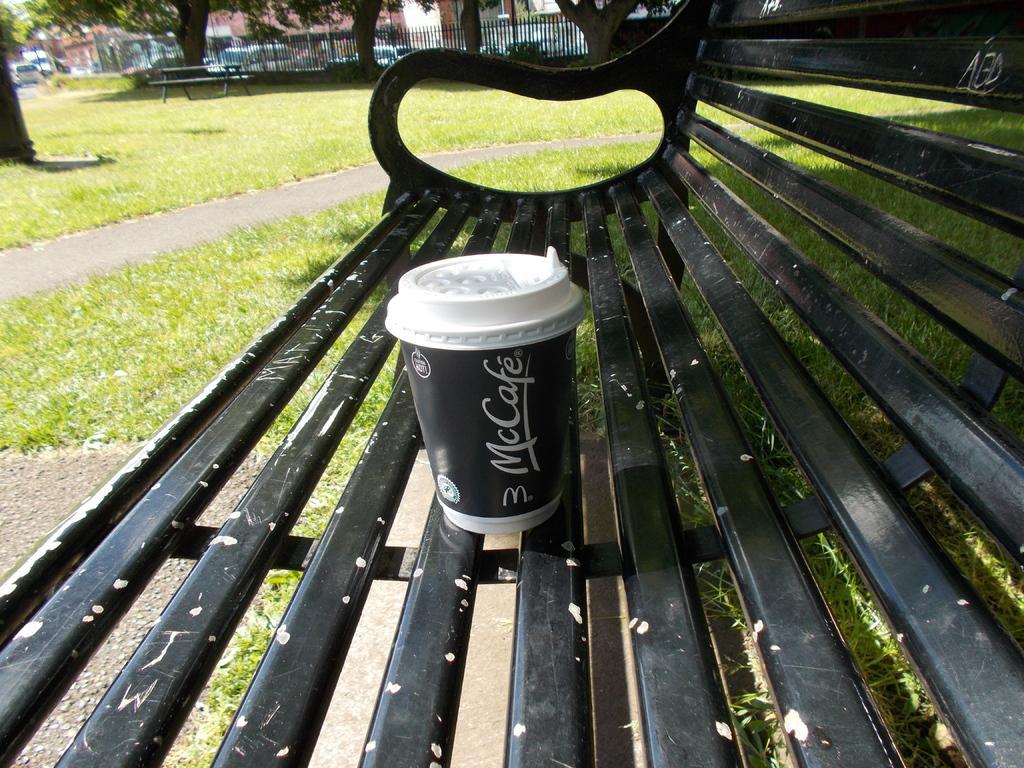Could you give a brief overview of what you see in this image? In front of the picture, we see a black color bench. On the bench, we see a black cup. Beside that, we see the grass. In the background, we see a bench, railing, trees, buildings and vehicles which are moving on the road. 